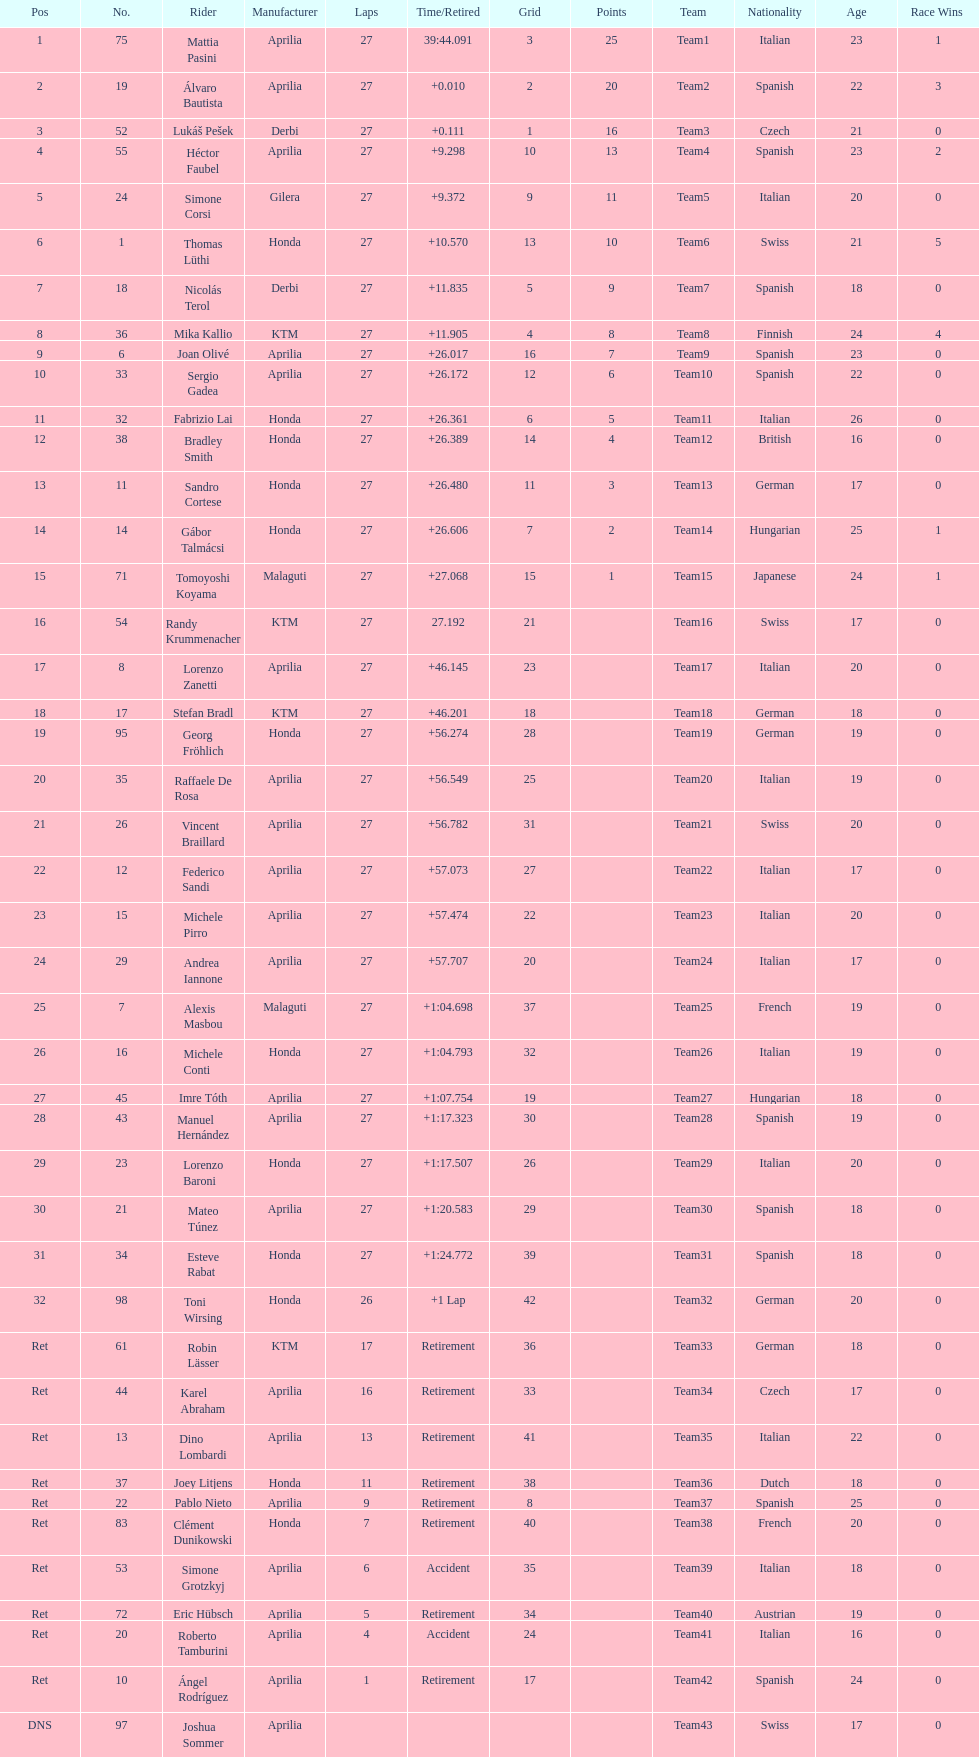How many racers did not use an aprilia or a honda? 9. 